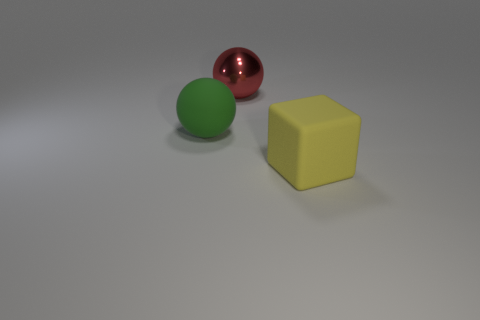Add 3 small green balls. How many objects exist? 6 Subtract all cubes. How many objects are left? 2 Add 1 large green spheres. How many large green spheres exist? 2 Subtract 0 purple cylinders. How many objects are left? 3 Subtract all large green rubber things. Subtract all red spheres. How many objects are left? 1 Add 3 large shiny objects. How many large shiny objects are left? 4 